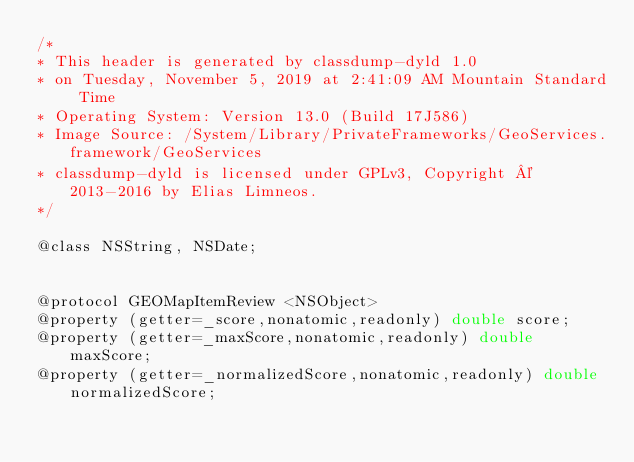<code> <loc_0><loc_0><loc_500><loc_500><_C_>/*
* This header is generated by classdump-dyld 1.0
* on Tuesday, November 5, 2019 at 2:41:09 AM Mountain Standard Time
* Operating System: Version 13.0 (Build 17J586)
* Image Source: /System/Library/PrivateFrameworks/GeoServices.framework/GeoServices
* classdump-dyld is licensed under GPLv3, Copyright © 2013-2016 by Elias Limneos.
*/

@class NSString, NSDate;


@protocol GEOMapItemReview <NSObject>
@property (getter=_score,nonatomic,readonly) double score; 
@property (getter=_maxScore,nonatomic,readonly) double maxScore; 
@property (getter=_normalizedScore,nonatomic,readonly) double normalizedScore; </code> 